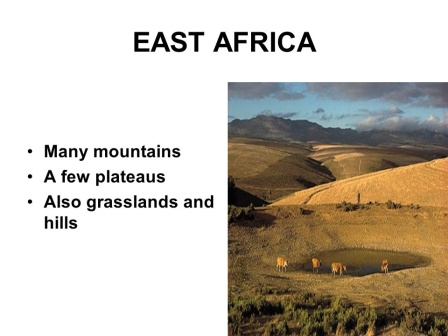What are the major geographical features present in the image? The image showcases a variety of geographical features characteristic of East Africa. Prominently, there are vast grasslands and gently rolling hills spread out across the valley floor. In the background, rugged mountains rise majestically, creating a dramatic backdrop. Interspersed within the valley are plateaus, offering elevated flat surfaces amidst the undulating terrain. The dirt paths winding through the grasslands provide natural pathways for the wildlife, including the elephants depicted in the foreground. The sky above is expansive and clear, adding a sense of openness and freedom to the scene. These geographical features together paint a picture of a diverse and dynamic landscape teeming with natural beauty. 